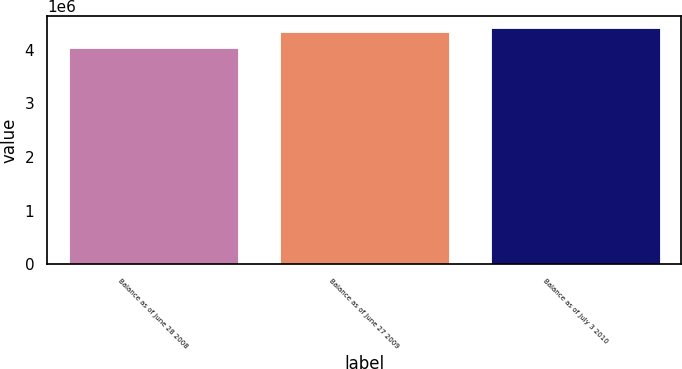Convert chart to OTSL. <chart><loc_0><loc_0><loc_500><loc_500><bar_chart><fcel>Balance as of June 28 2008<fcel>Balance as of June 27 2009<fcel>Balance as of July 3 2010<nl><fcel>4.04106e+06<fcel>4.33773e+06<fcel>4.40837e+06<nl></chart> 